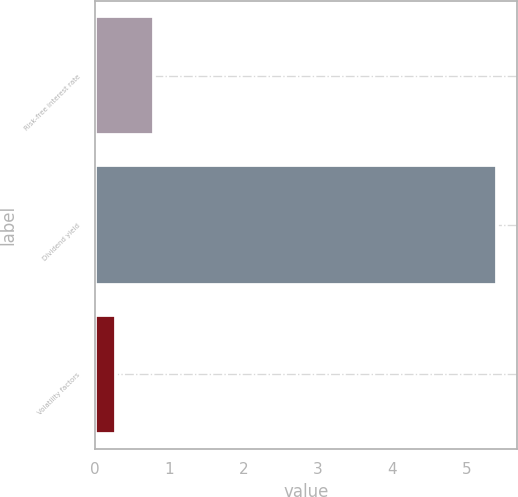Convert chart. <chart><loc_0><loc_0><loc_500><loc_500><bar_chart><fcel>Risk-free interest rate<fcel>Dividend yield<fcel>Volatility factors<nl><fcel>0.79<fcel>5.4<fcel>0.28<nl></chart> 